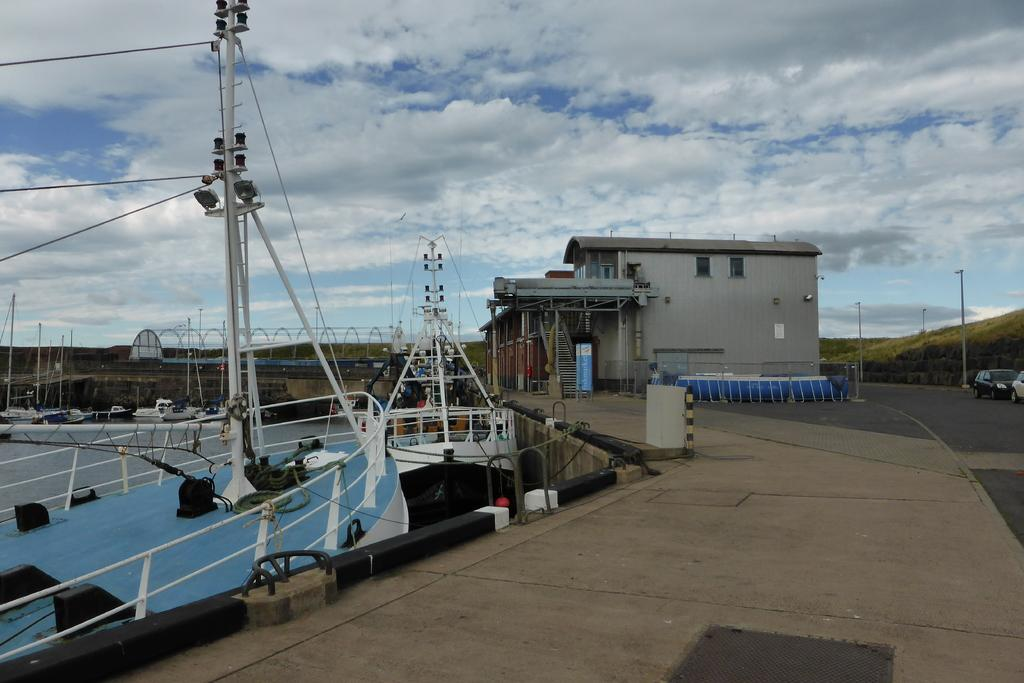What is the main subject of the image? The main subject of the image is boats on a water body. What can be seen in the background of the image? There is a building in the background of the image. What type of vehicles are moving in the image? Two cars are moving on the road in the image. What type of lighting is present in the image? There are street lights in the image. How would you describe the weather in the image? The sky is cloudy in the image. Are there any cacti visible in the image? No, there are no cacti present in the image. 